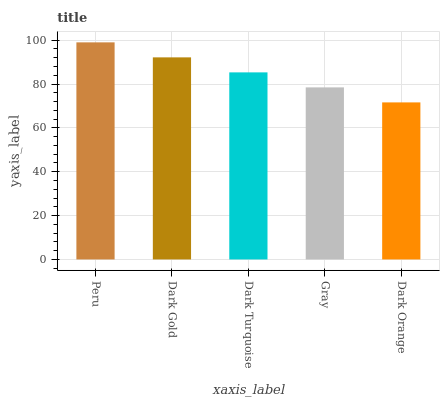Is Dark Orange the minimum?
Answer yes or no. Yes. Is Peru the maximum?
Answer yes or no. Yes. Is Dark Gold the minimum?
Answer yes or no. No. Is Dark Gold the maximum?
Answer yes or no. No. Is Peru greater than Dark Gold?
Answer yes or no. Yes. Is Dark Gold less than Peru?
Answer yes or no. Yes. Is Dark Gold greater than Peru?
Answer yes or no. No. Is Peru less than Dark Gold?
Answer yes or no. No. Is Dark Turquoise the high median?
Answer yes or no. Yes. Is Dark Turquoise the low median?
Answer yes or no. Yes. Is Dark Orange the high median?
Answer yes or no. No. Is Dark Gold the low median?
Answer yes or no. No. 